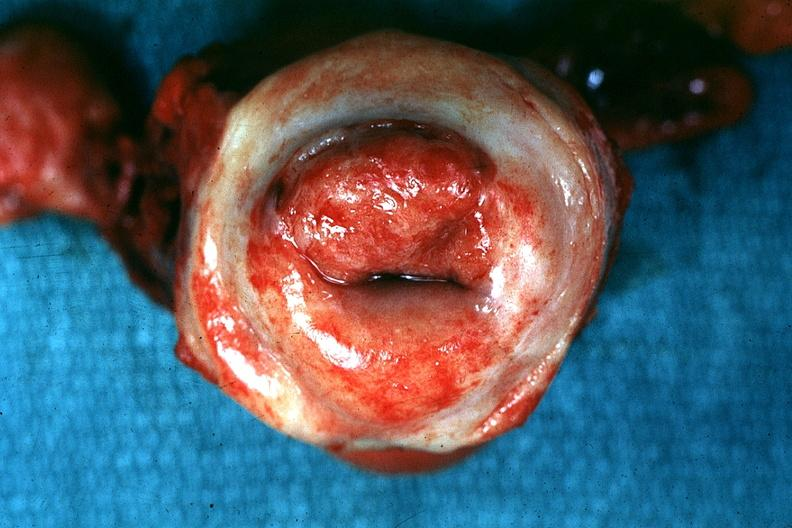what is present?
Answer the question using a single word or phrase. Female reproductive 